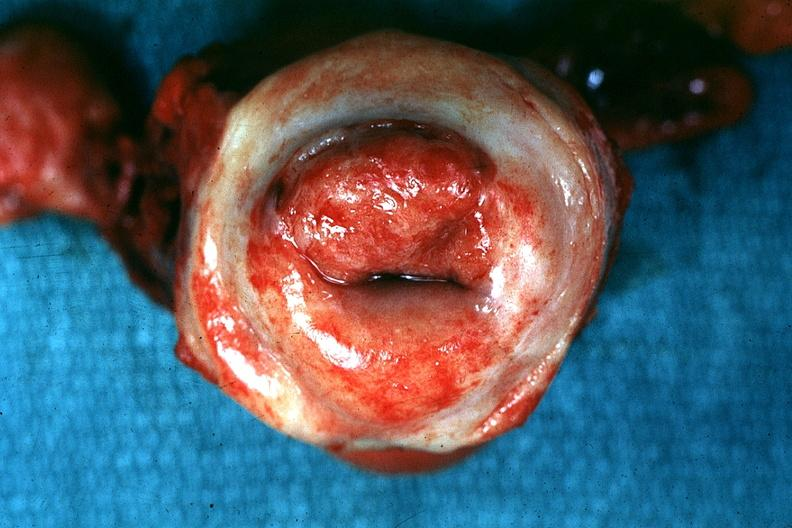what is present?
Answer the question using a single word or phrase. Female reproductive 